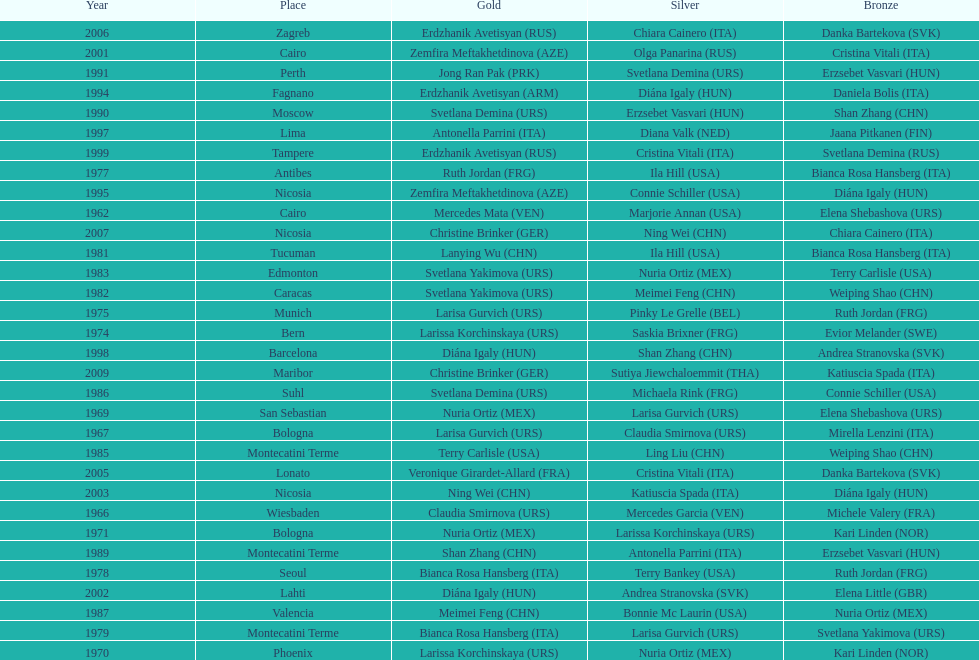Which country has won more gold medals: china or mexico? China. 